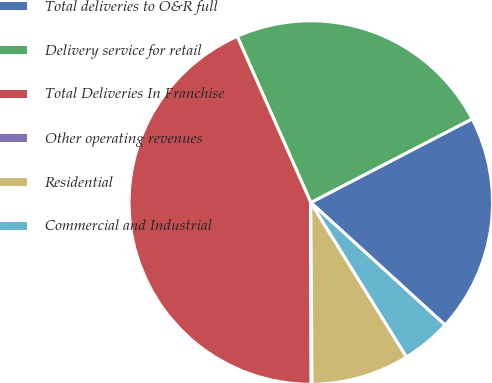Convert chart. <chart><loc_0><loc_0><loc_500><loc_500><pie_chart><fcel>Total deliveries to O&R full<fcel>Delivery service for retail<fcel>Total Deliveries In Franchise<fcel>Other operating revenues<fcel>Residential<fcel>Commercial and Industrial<nl><fcel>19.38%<fcel>24.02%<fcel>43.4%<fcel>0.07%<fcel>8.73%<fcel>4.4%<nl></chart> 